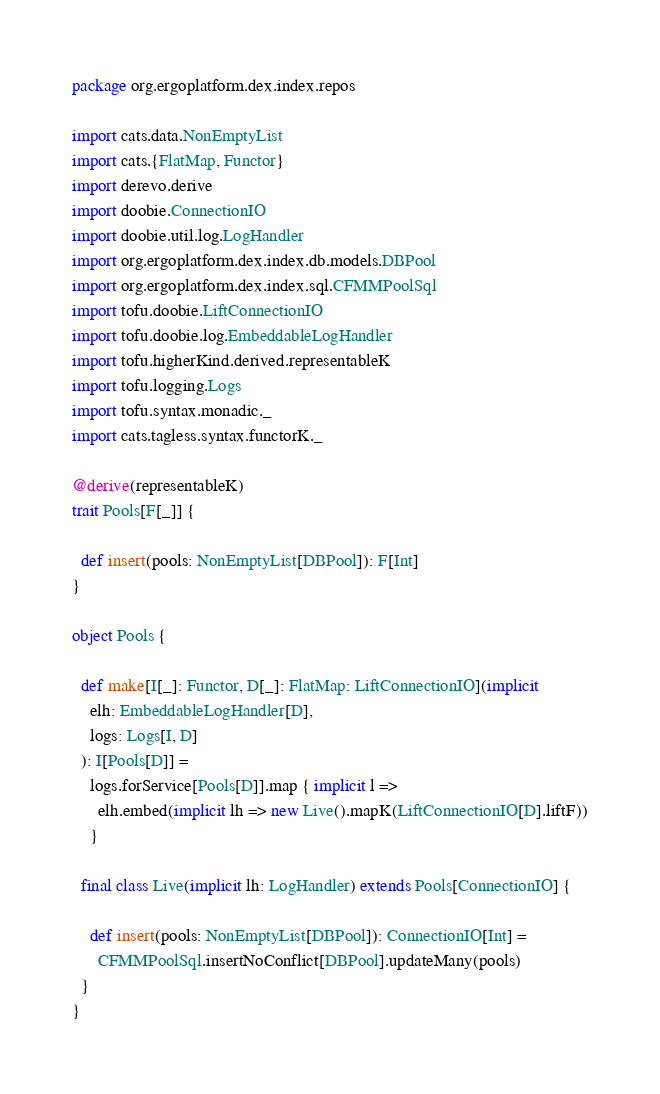Convert code to text. <code><loc_0><loc_0><loc_500><loc_500><_Scala_>package org.ergoplatform.dex.index.repos

import cats.data.NonEmptyList
import cats.{FlatMap, Functor}
import derevo.derive
import doobie.ConnectionIO
import doobie.util.log.LogHandler
import org.ergoplatform.dex.index.db.models.DBPool
import org.ergoplatform.dex.index.sql.CFMMPoolSql
import tofu.doobie.LiftConnectionIO
import tofu.doobie.log.EmbeddableLogHandler
import tofu.higherKind.derived.representableK
import tofu.logging.Logs
import tofu.syntax.monadic._
import cats.tagless.syntax.functorK._

@derive(representableK)
trait Pools[F[_]] {

  def insert(pools: NonEmptyList[DBPool]): F[Int]
}

object Pools {

  def make[I[_]: Functor, D[_]: FlatMap: LiftConnectionIO](implicit
    elh: EmbeddableLogHandler[D],
    logs: Logs[I, D]
  ): I[Pools[D]] =
    logs.forService[Pools[D]].map { implicit l =>
      elh.embed(implicit lh => new Live().mapK(LiftConnectionIO[D].liftF))
    }

  final class Live(implicit lh: LogHandler) extends Pools[ConnectionIO] {

    def insert(pools: NonEmptyList[DBPool]): ConnectionIO[Int] =
      CFMMPoolSql.insertNoConflict[DBPool].updateMany(pools)
  }
}
</code> 